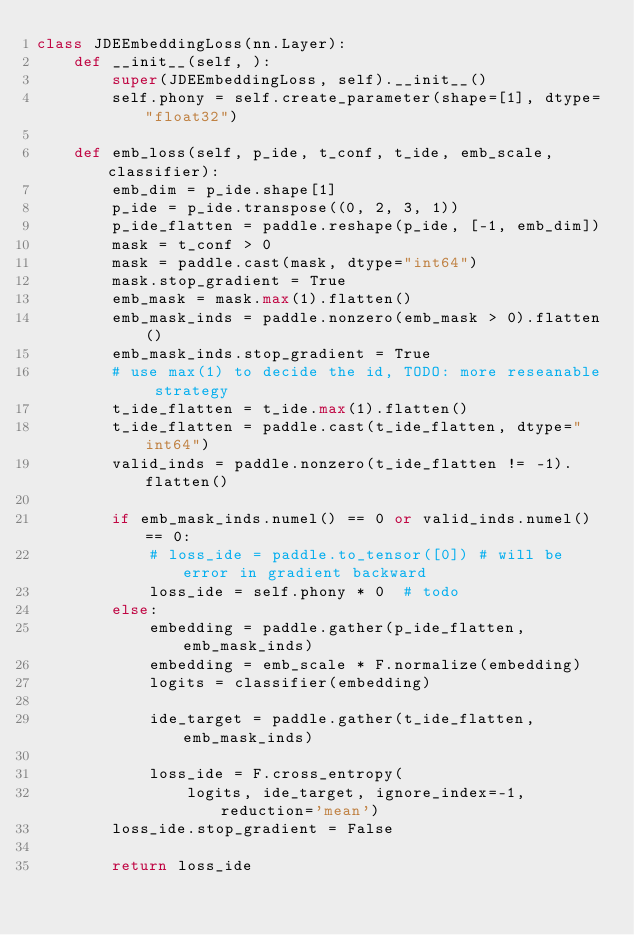<code> <loc_0><loc_0><loc_500><loc_500><_Python_>class JDEEmbeddingLoss(nn.Layer):
    def __init__(self, ):
        super(JDEEmbeddingLoss, self).__init__()
        self.phony = self.create_parameter(shape=[1], dtype="float32")

    def emb_loss(self, p_ide, t_conf, t_ide, emb_scale, classifier):
        emb_dim = p_ide.shape[1]
        p_ide = p_ide.transpose((0, 2, 3, 1))
        p_ide_flatten = paddle.reshape(p_ide, [-1, emb_dim])
        mask = t_conf > 0
        mask = paddle.cast(mask, dtype="int64")
        mask.stop_gradient = True
        emb_mask = mask.max(1).flatten()
        emb_mask_inds = paddle.nonzero(emb_mask > 0).flatten()
        emb_mask_inds.stop_gradient = True
        # use max(1) to decide the id, TODO: more reseanable strategy
        t_ide_flatten = t_ide.max(1).flatten()
        t_ide_flatten = paddle.cast(t_ide_flatten, dtype="int64")
        valid_inds = paddle.nonzero(t_ide_flatten != -1).flatten()

        if emb_mask_inds.numel() == 0 or valid_inds.numel() == 0:
            # loss_ide = paddle.to_tensor([0]) # will be error in gradient backward
            loss_ide = self.phony * 0  # todo
        else:
            embedding = paddle.gather(p_ide_flatten, emb_mask_inds)
            embedding = emb_scale * F.normalize(embedding)
            logits = classifier(embedding)

            ide_target = paddle.gather(t_ide_flatten, emb_mask_inds)

            loss_ide = F.cross_entropy(
                logits, ide_target, ignore_index=-1, reduction='mean')
        loss_ide.stop_gradient = False

        return loss_ide
</code> 